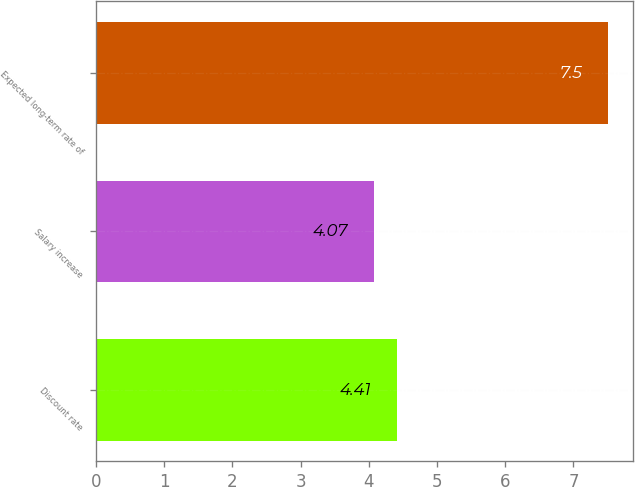Convert chart to OTSL. <chart><loc_0><loc_0><loc_500><loc_500><bar_chart><fcel>Discount rate<fcel>Salary increase<fcel>Expected long-term rate of<nl><fcel>4.41<fcel>4.07<fcel>7.5<nl></chart> 